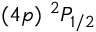<formula> <loc_0><loc_0><loc_500><loc_500>( 4 p ) ^ { 2 } P _ { 1 / 2 }</formula> 